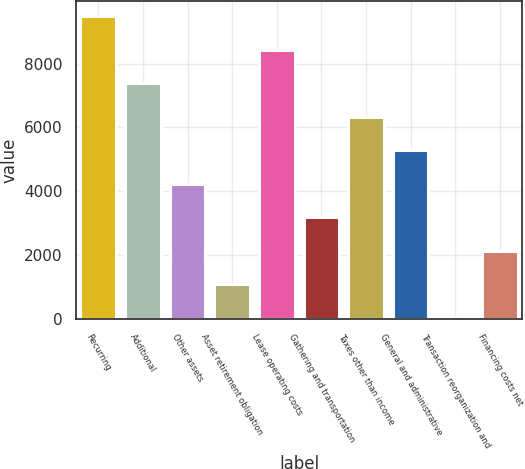Convert chart. <chart><loc_0><loc_0><loc_500><loc_500><bar_chart><fcel>Recurring<fcel>Additional<fcel>Other assets<fcel>Asset retirement obligation<fcel>Lease operating costs<fcel>Gathering and transportation<fcel>Taxes other than income<fcel>General and administrative<fcel>Transaction reorganization and<fcel>Financing costs net<nl><fcel>9480.3<fcel>7380.9<fcel>4231.8<fcel>1082.7<fcel>8430.6<fcel>3182.1<fcel>6331.2<fcel>5281.5<fcel>33<fcel>2132.4<nl></chart> 